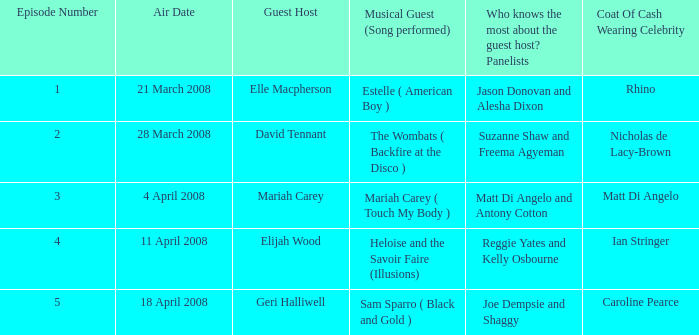Name the total number of coat of cash wearing celebrity where panelists are matt di angelo and antony cotton 1.0. 